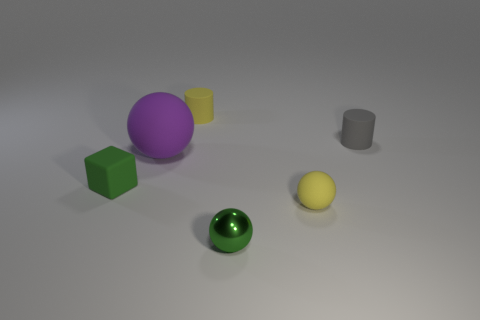Is there any other thing that is the same color as the metal object? Yes, the sphere in the center appears to be of a similar shiny metallic green as the metal object, reflecting light in a comparable manner which suggests they have similar material properties. 